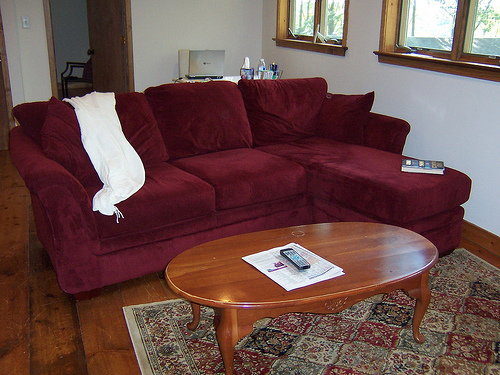<image>
Can you confirm if the sofa is next to the window pane? Yes. The sofa is positioned adjacent to the window pane, located nearby in the same general area. Is the remote under the table? No. The remote is not positioned under the table. The vertical relationship between these objects is different. 